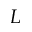Convert formula to latex. <formula><loc_0><loc_0><loc_500><loc_500>L</formula> 